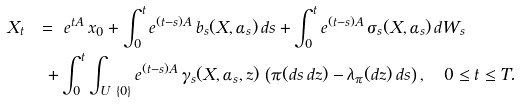Convert formula to latex. <formula><loc_0><loc_0><loc_500><loc_500>X _ { t } \ & = \ e ^ { t A } \, x _ { 0 } + \int _ { 0 } ^ { t } e ^ { ( t - s ) A } \, b _ { s } ( X , \alpha _ { s } ) \, d s + \int _ { 0 } ^ { t } e ^ { ( t - s ) A } \, \sigma _ { s } ( X , \alpha _ { s } ) \, d W _ { s } \\ & \ + \int _ { 0 } ^ { t } \int _ { U \ \{ 0 \} } e ^ { ( t - s ) A } \, \gamma _ { s } ( X , \alpha _ { s } , z ) \, \left ( \pi ( d s \, d z ) - \lambda _ { \pi } ( d z ) \, d s \right ) , \quad 0 \leq t \leq T .</formula> 